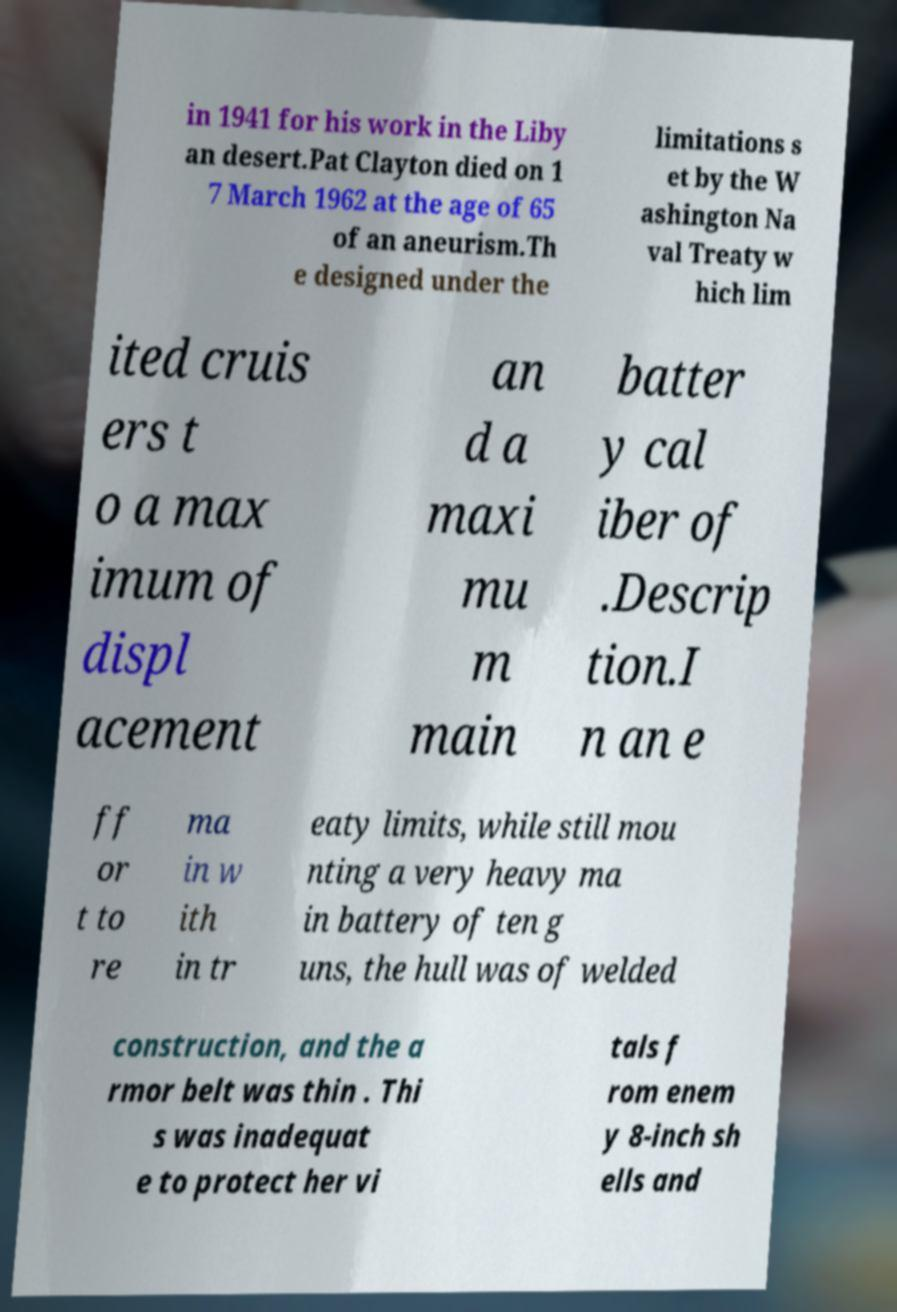Can you read and provide the text displayed in the image?This photo seems to have some interesting text. Can you extract and type it out for me? in 1941 for his work in the Liby an desert.Pat Clayton died on 1 7 March 1962 at the age of 65 of an aneurism.Th e designed under the limitations s et by the W ashington Na val Treaty w hich lim ited cruis ers t o a max imum of displ acement an d a maxi mu m main batter y cal iber of .Descrip tion.I n an e ff or t to re ma in w ith in tr eaty limits, while still mou nting a very heavy ma in battery of ten g uns, the hull was of welded construction, and the a rmor belt was thin . Thi s was inadequat e to protect her vi tals f rom enem y 8-inch sh ells and 